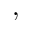Convert formula to latex. <formula><loc_0><loc_0><loc_500><loc_500>,</formula> 